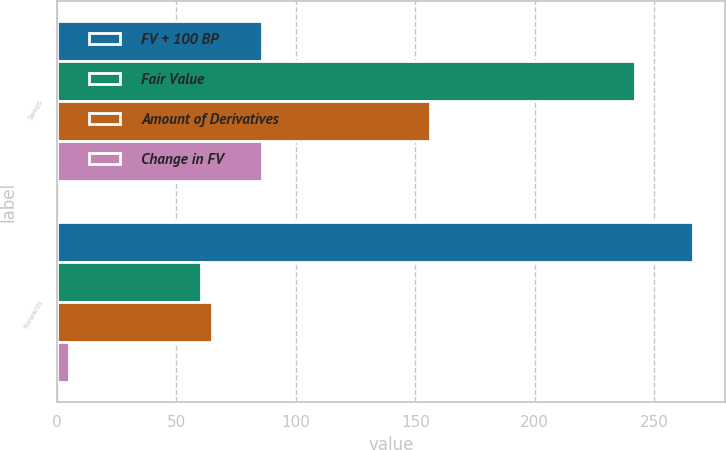Convert chart. <chart><loc_0><loc_0><loc_500><loc_500><stacked_bar_chart><ecel><fcel>Swaps<fcel>Forwards<nl><fcel>FV + 100 BP<fcel>86<fcel>266.3<nl><fcel>Fair Value<fcel>242.2<fcel>60.2<nl><fcel>Amount of Derivatives<fcel>156.2<fcel>65<nl><fcel>Change in FV<fcel>86<fcel>4.8<nl></chart> 